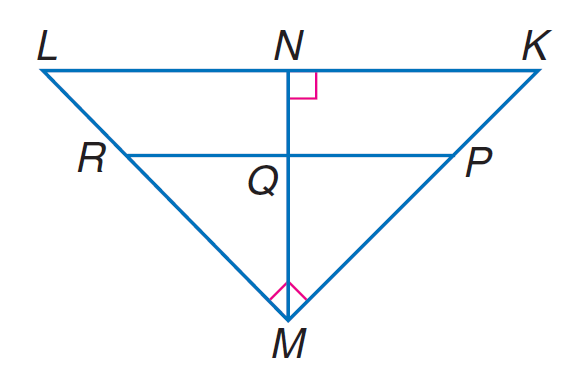Answer the mathemtical geometry problem and directly provide the correct option letter.
Question: If P R \parallel K L, K N = 9, L N = 16, P M = 2 K P, find K P.
Choices: A: 5 B: 7 C: 8 D: 14 A 